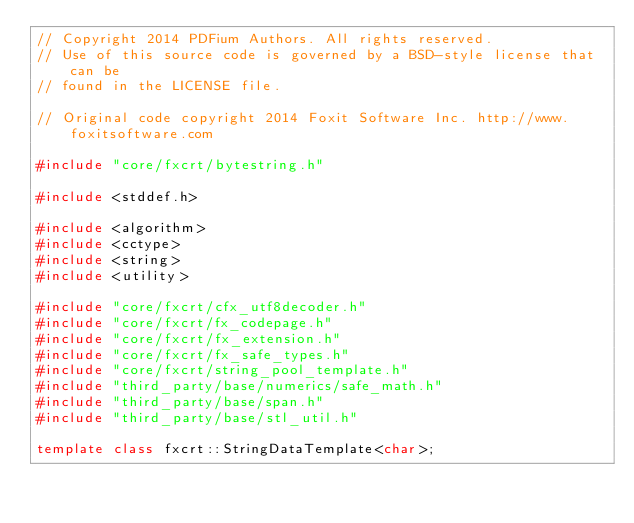Convert code to text. <code><loc_0><loc_0><loc_500><loc_500><_C++_>// Copyright 2014 PDFium Authors. All rights reserved.
// Use of this source code is governed by a BSD-style license that can be
// found in the LICENSE file.

// Original code copyright 2014 Foxit Software Inc. http://www.foxitsoftware.com

#include "core/fxcrt/bytestring.h"

#include <stddef.h>

#include <algorithm>
#include <cctype>
#include <string>
#include <utility>

#include "core/fxcrt/cfx_utf8decoder.h"
#include "core/fxcrt/fx_codepage.h"
#include "core/fxcrt/fx_extension.h"
#include "core/fxcrt/fx_safe_types.h"
#include "core/fxcrt/string_pool_template.h"
#include "third_party/base/numerics/safe_math.h"
#include "third_party/base/span.h"
#include "third_party/base/stl_util.h"

template class fxcrt::StringDataTemplate<char>;</code> 